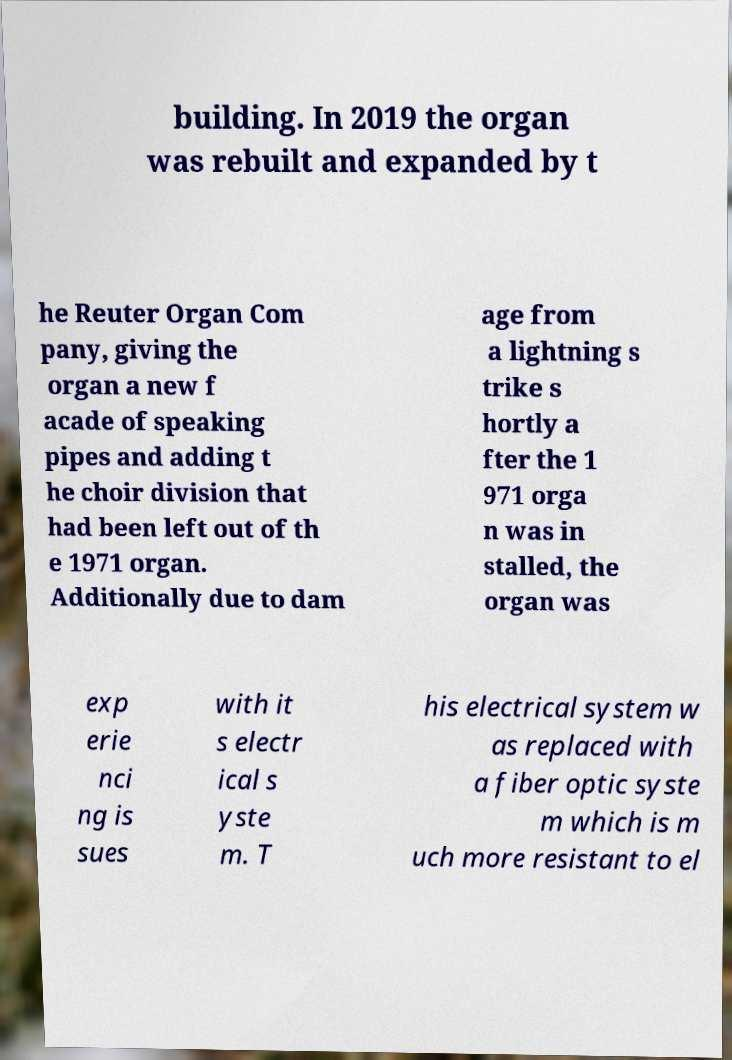Can you accurately transcribe the text from the provided image for me? building. In 2019 the organ was rebuilt and expanded by t he Reuter Organ Com pany, giving the organ a new f acade of speaking pipes and adding t he choir division that had been left out of th e 1971 organ. Additionally due to dam age from a lightning s trike s hortly a fter the 1 971 orga n was in stalled, the organ was exp erie nci ng is sues with it s electr ical s yste m. T his electrical system w as replaced with a fiber optic syste m which is m uch more resistant to el 